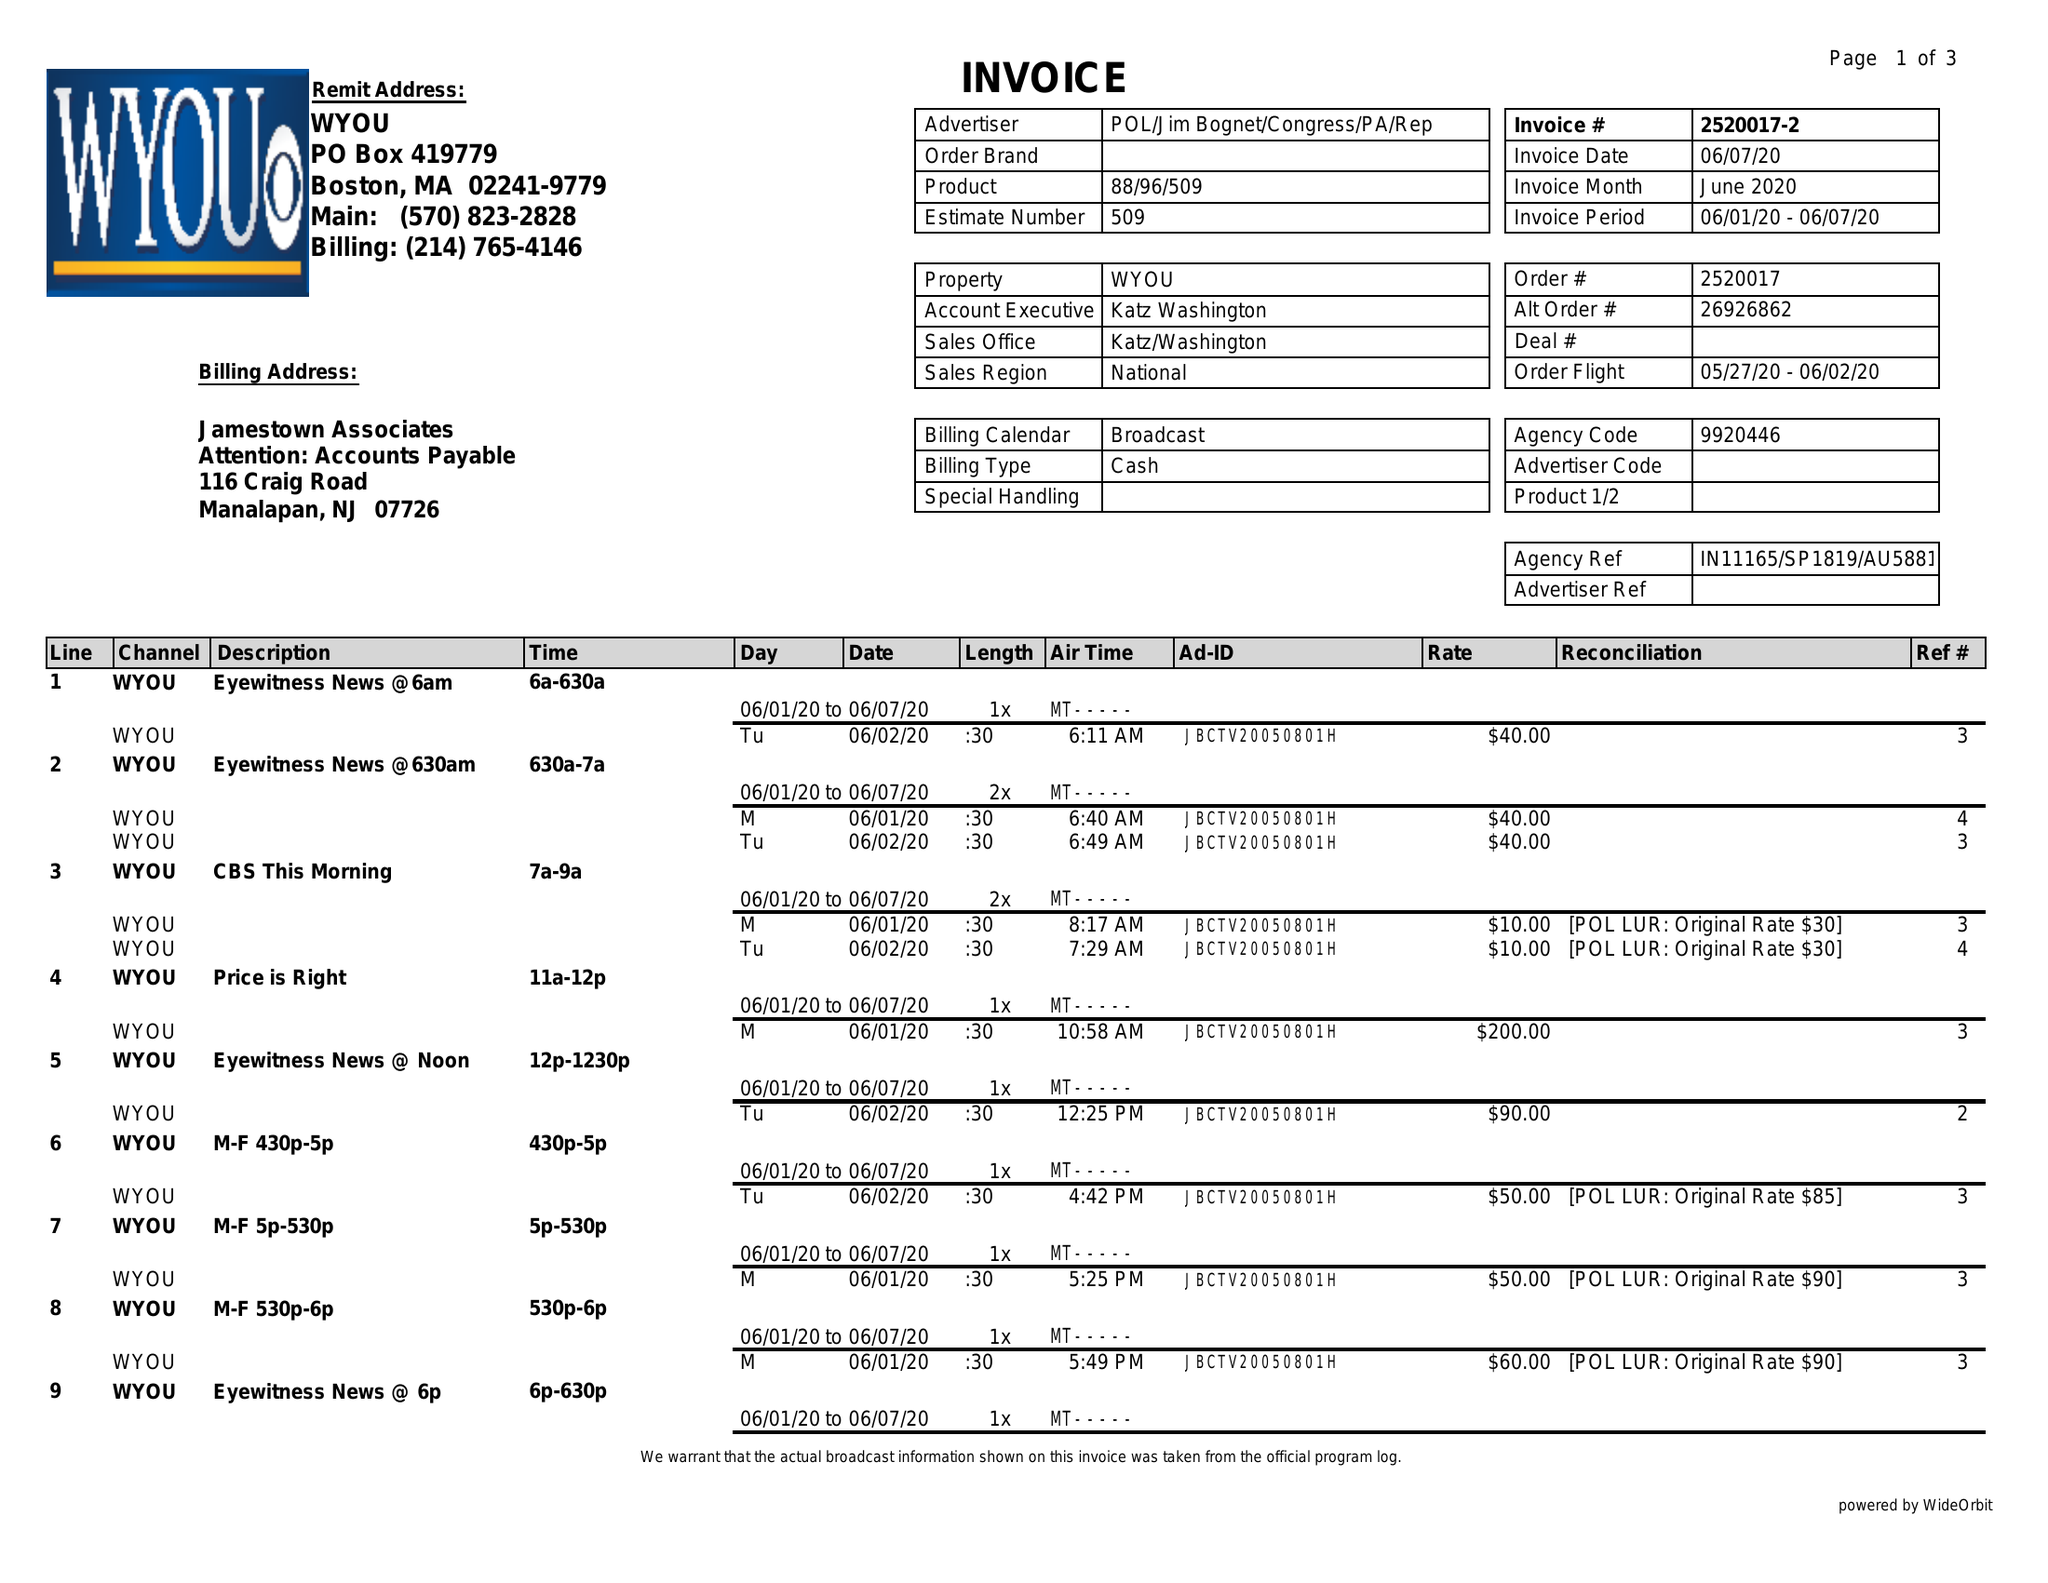What is the value for the advertiser?
Answer the question using a single word or phrase. POL/JIMBOGNET/CONGRESS/PA/REP 